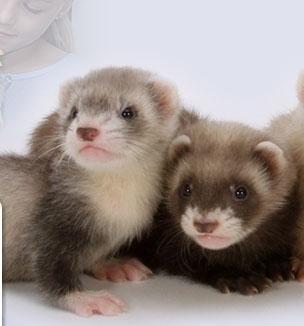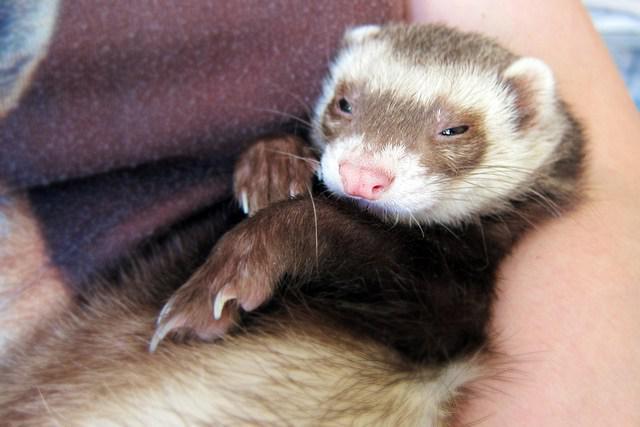The first image is the image on the left, the second image is the image on the right. Examine the images to the left and right. Is the description "At least one image contains a cream colored and a masked ferret." accurate? Answer yes or no. No. 